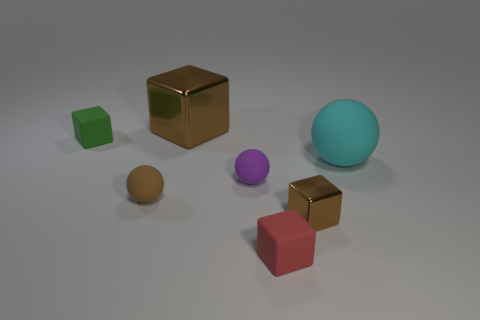Subtract 1 cubes. How many cubes are left? 3 Subtract all purple cubes. Subtract all yellow spheres. How many cubes are left? 4 Add 3 large brown cylinders. How many objects exist? 10 Subtract all cubes. How many objects are left? 3 Add 4 balls. How many balls exist? 7 Subtract 0 brown cylinders. How many objects are left? 7 Subtract all small matte cubes. Subtract all green matte cubes. How many objects are left? 4 Add 1 purple matte objects. How many purple matte objects are left? 2 